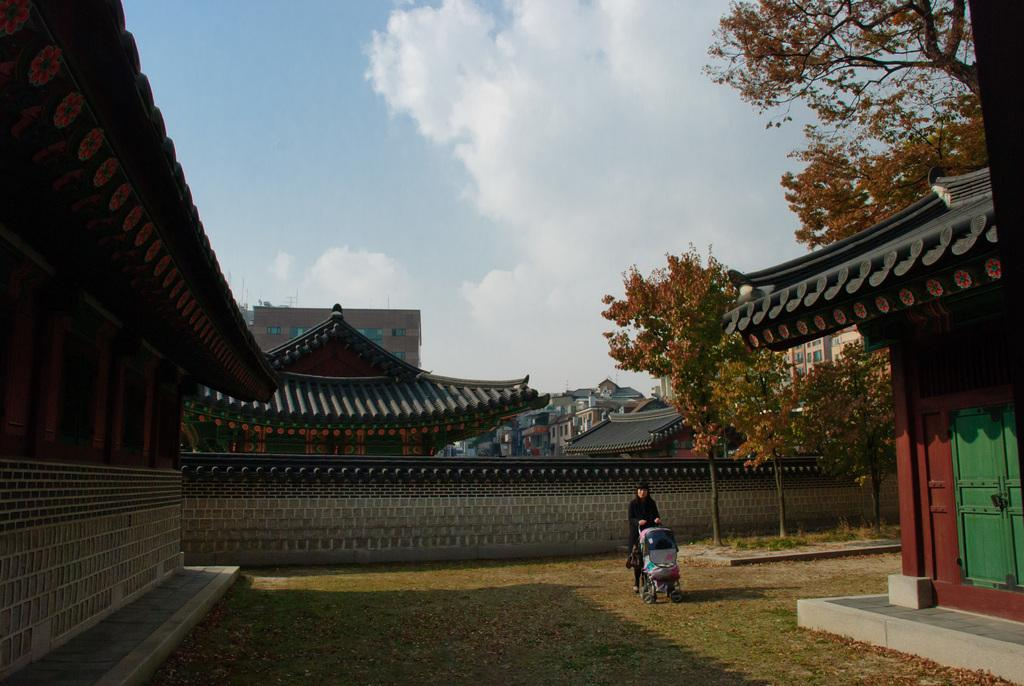What is the main subject of the image? There is a person in the image. Can you describe the person's attire? The person is wearing a black dress. What is the person doing in the image? The person is standing and holding an object in her hand. What can be seen in the background of the image? There are buildings, trees, and the sky visible in the background of the image. What year is depicted in the image? The image does not depict a specific year; it is a photograph of a person standing and holding an object. What type of plate is being used by the person in the image? There is no plate present in the image; the person is holding an unspecified object. 